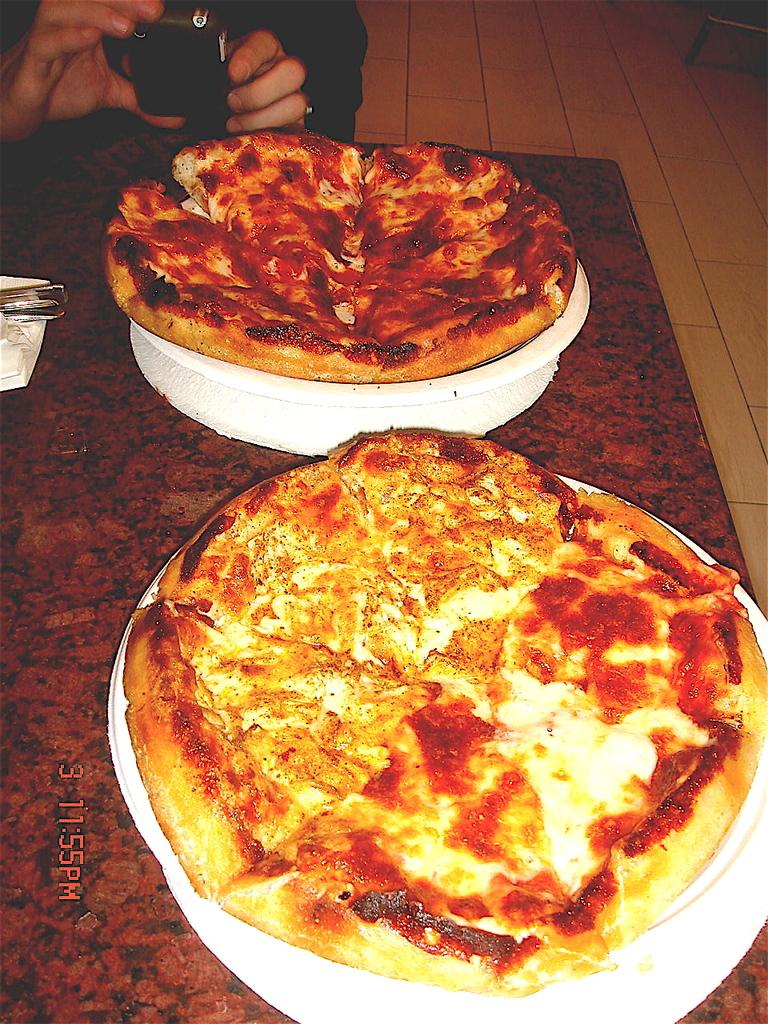What type of food is visible in the foreground of the image? There are two pizzas on platters in the foreground of the image. What is the man in the image doing? The man is holding a camera in the image. What can be seen beneath the pizzas and the man? The floor is visible in the image. Can you tell me how many pencils are on the ocean in the image? There are no pencils or ocean present in the image; it features two pizzas on platters and a man holding a camera. 